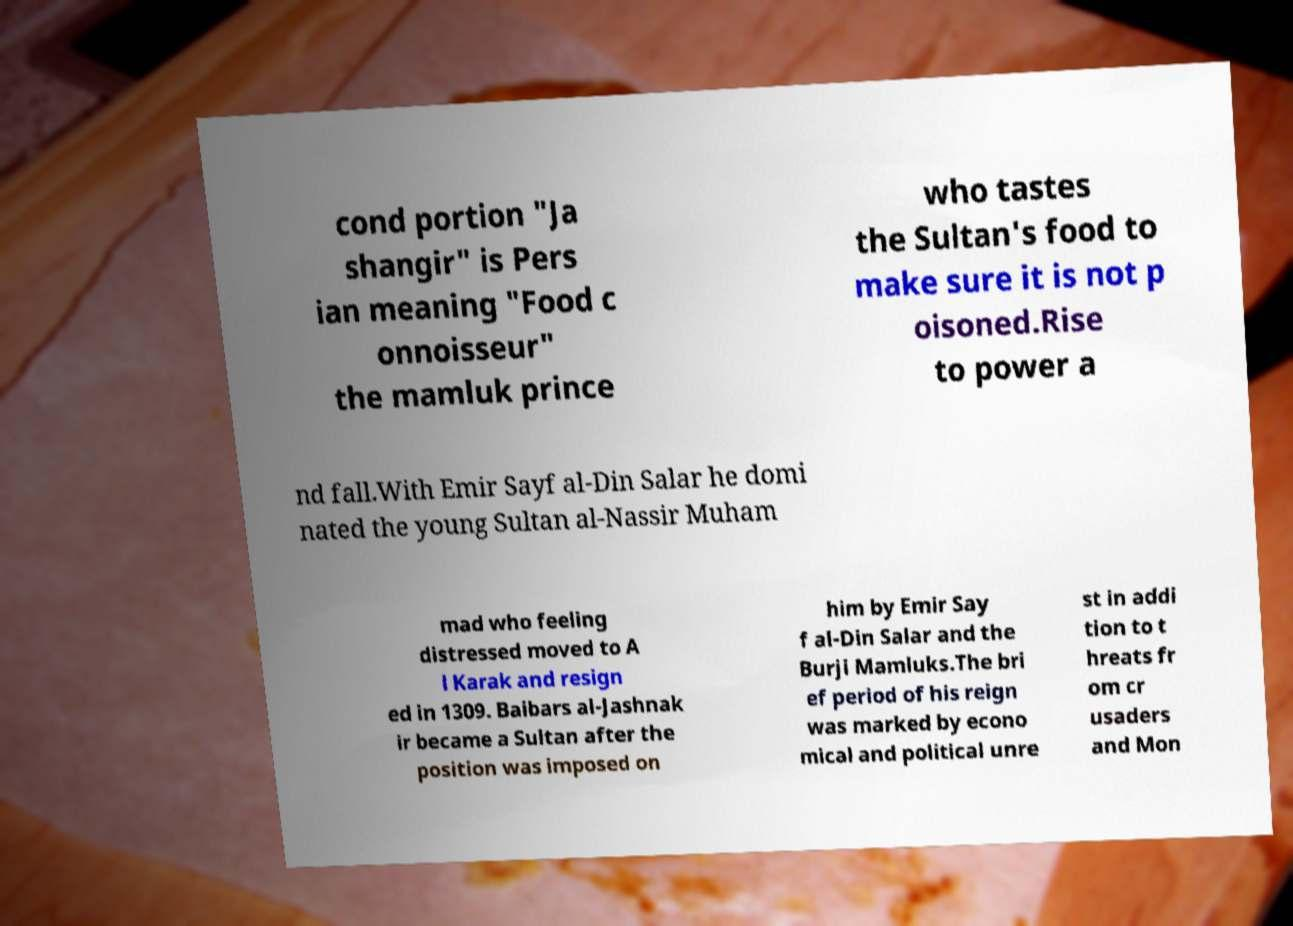For documentation purposes, I need the text within this image transcribed. Could you provide that? cond portion "Ja shangir" is Pers ian meaning "Food c onnoisseur" the mamluk prince who tastes the Sultan's food to make sure it is not p oisoned.Rise to power a nd fall.With Emir Sayf al-Din Salar he domi nated the young Sultan al-Nassir Muham mad who feeling distressed moved to A l Karak and resign ed in 1309. Baibars al-Jashnak ir became a Sultan after the position was imposed on him by Emir Say f al-Din Salar and the Burji Mamluks.The bri ef period of his reign was marked by econo mical and political unre st in addi tion to t hreats fr om cr usaders and Mon 